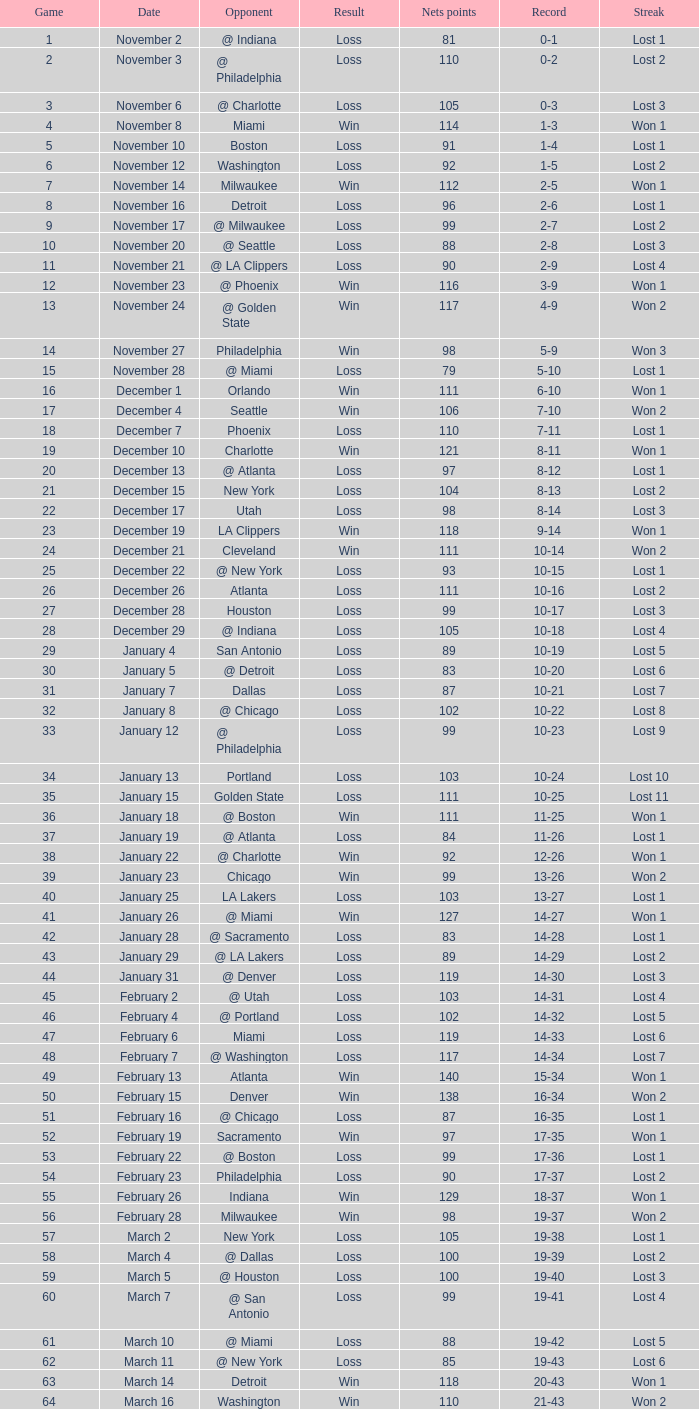What was the average point total for the nets in games before game 9 where the opponents scored less than 95? None. 